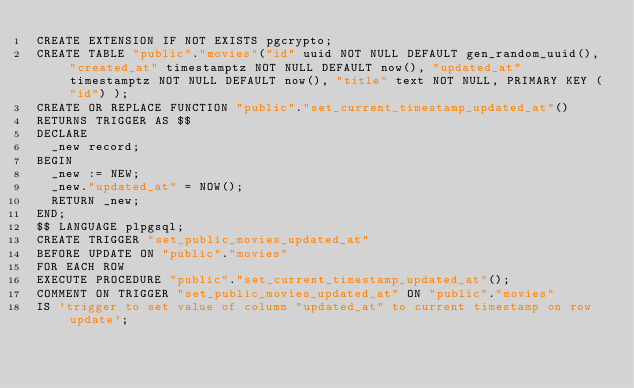Convert code to text. <code><loc_0><loc_0><loc_500><loc_500><_SQL_>CREATE EXTENSION IF NOT EXISTS pgcrypto;
CREATE TABLE "public"."movies"("id" uuid NOT NULL DEFAULT gen_random_uuid(), "created_at" timestamptz NOT NULL DEFAULT now(), "updated_at" timestamptz NOT NULL DEFAULT now(), "title" text NOT NULL, PRIMARY KEY ("id") );
CREATE OR REPLACE FUNCTION "public"."set_current_timestamp_updated_at"()
RETURNS TRIGGER AS $$
DECLARE
  _new record;
BEGIN
  _new := NEW;
  _new."updated_at" = NOW();
  RETURN _new;
END;
$$ LANGUAGE plpgsql;
CREATE TRIGGER "set_public_movies_updated_at"
BEFORE UPDATE ON "public"."movies"
FOR EACH ROW
EXECUTE PROCEDURE "public"."set_current_timestamp_updated_at"();
COMMENT ON TRIGGER "set_public_movies_updated_at" ON "public"."movies" 
IS 'trigger to set value of column "updated_at" to current timestamp on row update';
</code> 